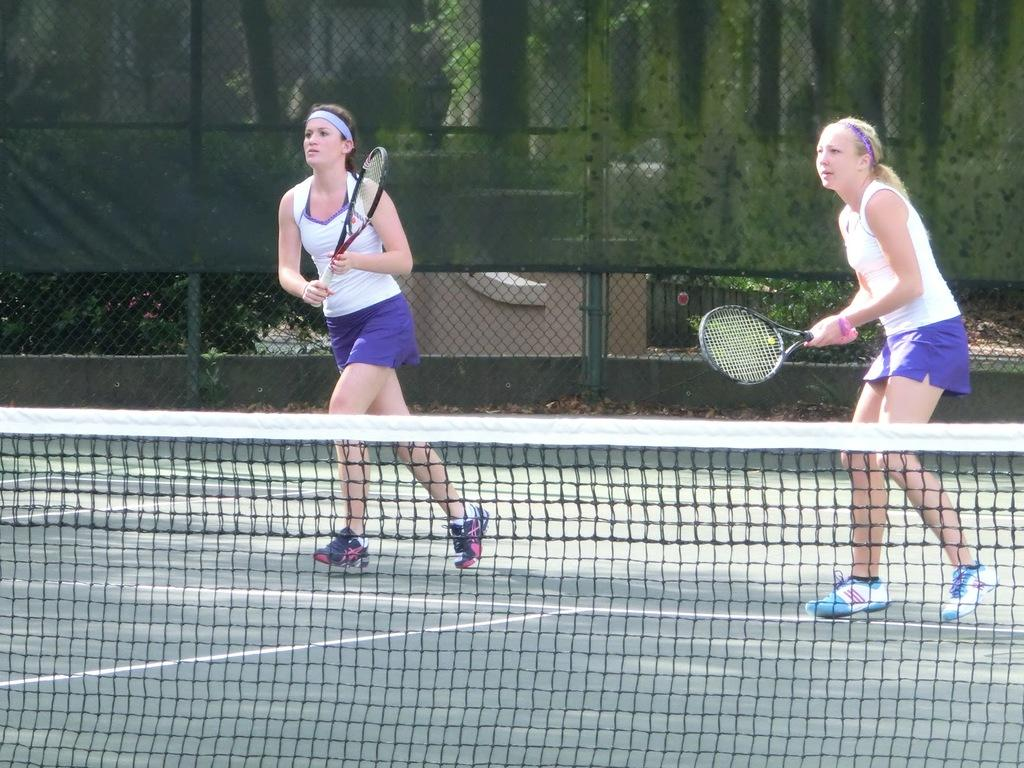How many people are in the image? There are two persons in the image. What activity are the two persons engaged in? The two persons are playing tennis. Where are they playing tennis? They are playing on a tennis court, which is visible in the image. What can be seen in the background of the image? There are trees visible in the background of the image. What type of bone is being used as a racket in the image? There is no bone being used as a racket in the image; the two persons are playing tennis with tennis rackets. How does the oatmeal affect the game of tennis in the image? There is no oatmeal present in the image, so it cannot affect the game of tennis. 